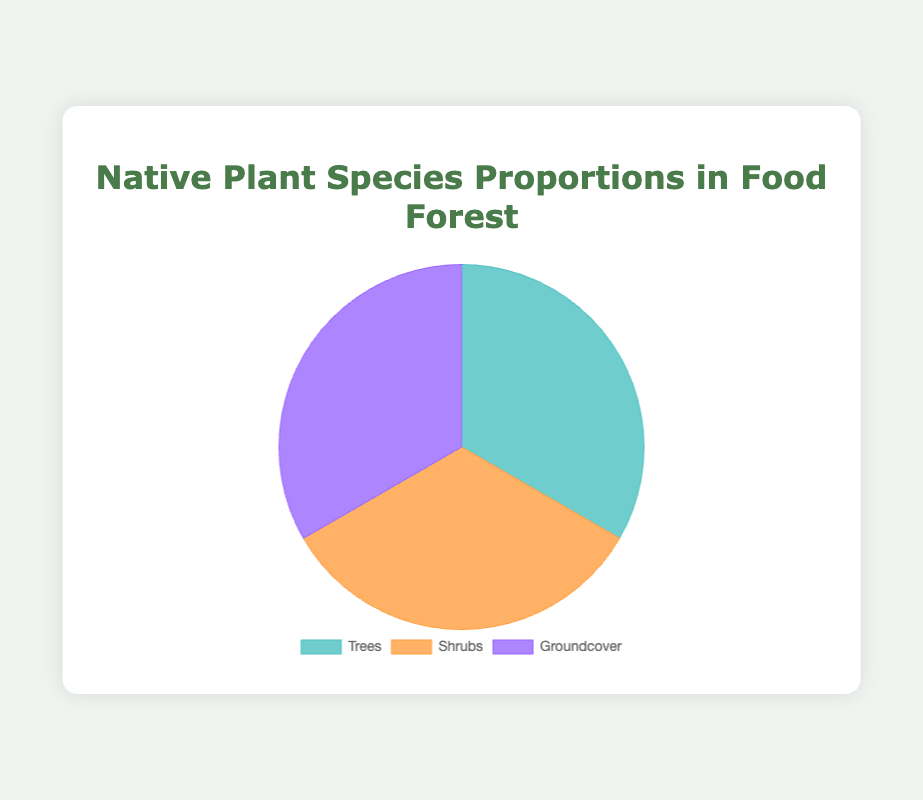Which type of native plant species has the highest proportion in the food forest? The pie chart shows the proportions for Trees, Shrubs, and Groundcover. Comparing the sections, each type has an equal proportion of 100%.
Answer: Trees, Shrubs, Groundcover What is the combined proportion of Highbush Blueberry and Wild Strawberry among their respective categories? Highbush Blueberry has 45% in the Shrubs category, and Wild Strawberry has 35% in the Groundcover category. Adding 45% and 35% gives 80%.
Answer: 80% Which category has a species with the smallest proportion, and what is that proportion? Each category's smallest proportion is examined: White Ash and Black Walnut (Trees) both have 10%, Staghorn Sumac (Shrubs) has 10%, and Bluebead Lily (Groundcover) has 10%. All are equal at 10%.
Answer: Trees, Shrubs, Groundcover; 10% What is the difference between the proportions of the most and least prevalent species in the Trees category? In the Trees category, the most prevalent is White Oak (35%) and the least is White Ash or Black Walnut (10%). The difference is 35% - 10% = 25%.
Answer: 25% Compare the highest proportion in Trees with the highest in Groundcover. Which is larger and by how much? The highest in Trees is White Oak at 35%, and in Groundcover, Eastern Teaberry at 40%. Groundcover's highest is 5% larger (40% - 35% = 5%).
Answer: Groundcover; 5% How many species in the Shrubs category have a proportion of 30% or more? The Shrubs category has Highbush Blueberry (45%) and American Elderberry (30%). So, 2 species meet the criterion.
Answer: 2 If you were to combine the proportions of Red Maple and Shagbark Hickory, what would their total proportion be within the Trees category? Red Maple has 25% and Shagbark Hickory has 20%. Summing them gives 25% + 20% = 45%.
Answer: 45% Which species in the Groundcover category has the second highest proportion, and what is it? The Groundcover category is reviewed: Eastern Teaberry (40%), Wild Strawberry (35%), Partridge Berry (15%), and Bluebead Lily (10%). Wild Strawberry is second highest at 35%.
Answer: Wild Strawberry; 35% What is the proportion difference between the highest species in the Shrubs category and the highest species in the Trees category? Highbush Blueberry (Shrubs) has 45%, and White Oak (Trees) has 35%. The difference is 45% - 35% = 10%.
Answer: 10% 